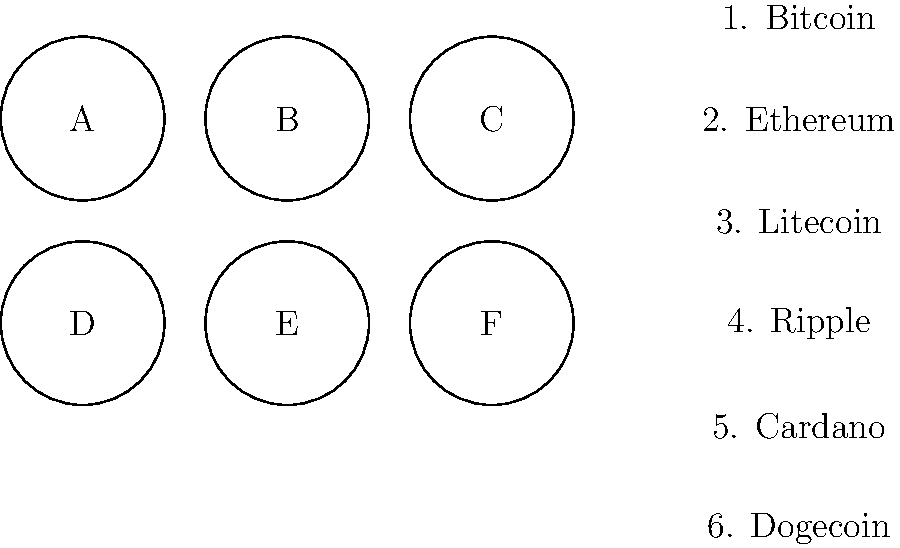Match the cryptocurrency logos (A-F) to their corresponding names (1-6). Which letter corresponds to the Ethereum logo? To answer this question, we need to analyze the commonly known logos of major cryptocurrencies and match them to the given options. Let's go through each logo:

1. Bitcoin (BTC) typically has a bold, orange "B" with two vertical lines through it.
2. Ethereum (ETH) usually features a diamond-shaped logo with two inverted triangles forming an "X" in the middle.
3. Litecoin (LTC) often has a silver "L" rotated at a 45-degree angle.
4. Ripple (XRP) commonly uses a circular logo with an "X" shape inside.
5. Cardano (ADA) typically has a circular logo with multiple layers, resembling a flower or atom.
6. Dogecoin (DOGE) features the famous Shiba Inu dog face from the "Doge" meme.

In the given grid, the logo that most closely resembles the Ethereum logo is "B". It shows a diamond shape with an "X" formed by two inverted triangles in the middle, which is the distinctive Ethereum logo.
Answer: B 